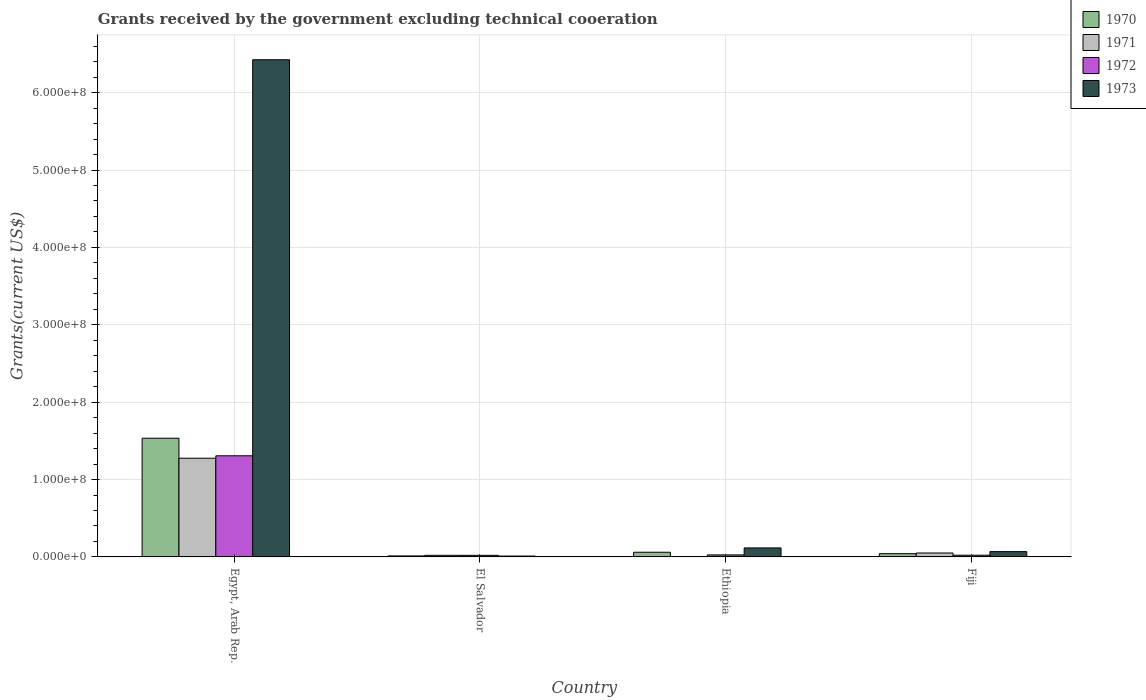How many different coloured bars are there?
Your answer should be compact. 4. How many groups of bars are there?
Offer a very short reply. 4. How many bars are there on the 2nd tick from the left?
Offer a terse response. 4. What is the label of the 2nd group of bars from the left?
Keep it short and to the point. El Salvador. In how many cases, is the number of bars for a given country not equal to the number of legend labels?
Offer a very short reply. 1. What is the total grants received by the government in 1973 in Fiji?
Offer a terse response. 6.86e+06. Across all countries, what is the maximum total grants received by the government in 1973?
Ensure brevity in your answer.  6.43e+08. Across all countries, what is the minimum total grants received by the government in 1973?
Your response must be concise. 1.15e+06. In which country was the total grants received by the government in 1970 maximum?
Your answer should be compact. Egypt, Arab Rep. What is the total total grants received by the government in 1971 in the graph?
Your response must be concise. 1.35e+08. What is the difference between the total grants received by the government in 1972 in El Salvador and that in Fiji?
Keep it short and to the point. -1.60e+05. What is the difference between the total grants received by the government in 1973 in El Salvador and the total grants received by the government in 1972 in Ethiopia?
Keep it short and to the point. -1.45e+06. What is the average total grants received by the government in 1973 per country?
Make the answer very short. 1.66e+08. What is the difference between the total grants received by the government of/in 1973 and total grants received by the government of/in 1970 in Ethiopia?
Keep it short and to the point. 5.60e+06. What is the ratio of the total grants received by the government in 1970 in El Salvador to that in Ethiopia?
Make the answer very short. 0.22. Is the difference between the total grants received by the government in 1973 in Ethiopia and Fiji greater than the difference between the total grants received by the government in 1970 in Ethiopia and Fiji?
Offer a terse response. Yes. What is the difference between the highest and the second highest total grants received by the government in 1972?
Keep it short and to the point. 1.28e+08. What is the difference between the highest and the lowest total grants received by the government in 1973?
Provide a short and direct response. 6.41e+08. In how many countries, is the total grants received by the government in 1971 greater than the average total grants received by the government in 1971 taken over all countries?
Offer a terse response. 1. Is the sum of the total grants received by the government in 1972 in Egypt, Arab Rep. and Ethiopia greater than the maximum total grants received by the government in 1971 across all countries?
Offer a very short reply. Yes. Is it the case that in every country, the sum of the total grants received by the government in 1970 and total grants received by the government in 1971 is greater than the total grants received by the government in 1973?
Provide a succinct answer. No. How many bars are there?
Ensure brevity in your answer.  15. How many countries are there in the graph?
Keep it short and to the point. 4. Does the graph contain grids?
Offer a terse response. Yes. How are the legend labels stacked?
Give a very brief answer. Vertical. What is the title of the graph?
Ensure brevity in your answer.  Grants received by the government excluding technical cooeration. Does "1980" appear as one of the legend labels in the graph?
Make the answer very short. No. What is the label or title of the Y-axis?
Keep it short and to the point. Grants(current US$). What is the Grants(current US$) in 1970 in Egypt, Arab Rep.?
Your answer should be compact. 1.53e+08. What is the Grants(current US$) in 1971 in Egypt, Arab Rep.?
Your response must be concise. 1.28e+08. What is the Grants(current US$) in 1972 in Egypt, Arab Rep.?
Give a very brief answer. 1.31e+08. What is the Grants(current US$) of 1973 in Egypt, Arab Rep.?
Keep it short and to the point. 6.43e+08. What is the Grants(current US$) in 1970 in El Salvador?
Your answer should be compact. 1.32e+06. What is the Grants(current US$) in 1971 in El Salvador?
Ensure brevity in your answer.  2.08e+06. What is the Grants(current US$) in 1972 in El Salvador?
Your answer should be very brief. 2.07e+06. What is the Grants(current US$) in 1973 in El Salvador?
Provide a succinct answer. 1.15e+06. What is the Grants(current US$) in 1970 in Ethiopia?
Provide a succinct answer. 6.05e+06. What is the Grants(current US$) of 1971 in Ethiopia?
Ensure brevity in your answer.  0. What is the Grants(current US$) of 1972 in Ethiopia?
Keep it short and to the point. 2.60e+06. What is the Grants(current US$) in 1973 in Ethiopia?
Keep it short and to the point. 1.16e+07. What is the Grants(current US$) in 1970 in Fiji?
Your response must be concise. 4.19e+06. What is the Grants(current US$) in 1971 in Fiji?
Make the answer very short. 5.09e+06. What is the Grants(current US$) of 1972 in Fiji?
Keep it short and to the point. 2.23e+06. What is the Grants(current US$) of 1973 in Fiji?
Provide a succinct answer. 6.86e+06. Across all countries, what is the maximum Grants(current US$) in 1970?
Your answer should be compact. 1.53e+08. Across all countries, what is the maximum Grants(current US$) of 1971?
Provide a short and direct response. 1.28e+08. Across all countries, what is the maximum Grants(current US$) in 1972?
Your answer should be compact. 1.31e+08. Across all countries, what is the maximum Grants(current US$) of 1973?
Make the answer very short. 6.43e+08. Across all countries, what is the minimum Grants(current US$) of 1970?
Keep it short and to the point. 1.32e+06. Across all countries, what is the minimum Grants(current US$) in 1971?
Ensure brevity in your answer.  0. Across all countries, what is the minimum Grants(current US$) of 1972?
Your response must be concise. 2.07e+06. Across all countries, what is the minimum Grants(current US$) of 1973?
Offer a terse response. 1.15e+06. What is the total Grants(current US$) of 1970 in the graph?
Offer a very short reply. 1.65e+08. What is the total Grants(current US$) in 1971 in the graph?
Your response must be concise. 1.35e+08. What is the total Grants(current US$) in 1972 in the graph?
Your answer should be compact. 1.38e+08. What is the total Grants(current US$) of 1973 in the graph?
Offer a very short reply. 6.62e+08. What is the difference between the Grants(current US$) in 1970 in Egypt, Arab Rep. and that in El Salvador?
Your answer should be very brief. 1.52e+08. What is the difference between the Grants(current US$) in 1971 in Egypt, Arab Rep. and that in El Salvador?
Make the answer very short. 1.26e+08. What is the difference between the Grants(current US$) in 1972 in Egypt, Arab Rep. and that in El Salvador?
Offer a terse response. 1.29e+08. What is the difference between the Grants(current US$) in 1973 in Egypt, Arab Rep. and that in El Salvador?
Provide a succinct answer. 6.41e+08. What is the difference between the Grants(current US$) in 1970 in Egypt, Arab Rep. and that in Ethiopia?
Your answer should be compact. 1.47e+08. What is the difference between the Grants(current US$) of 1972 in Egypt, Arab Rep. and that in Ethiopia?
Offer a very short reply. 1.28e+08. What is the difference between the Grants(current US$) of 1973 in Egypt, Arab Rep. and that in Ethiopia?
Provide a succinct answer. 6.31e+08. What is the difference between the Grants(current US$) of 1970 in Egypt, Arab Rep. and that in Fiji?
Your answer should be compact. 1.49e+08. What is the difference between the Grants(current US$) of 1971 in Egypt, Arab Rep. and that in Fiji?
Keep it short and to the point. 1.22e+08. What is the difference between the Grants(current US$) in 1972 in Egypt, Arab Rep. and that in Fiji?
Your answer should be compact. 1.28e+08. What is the difference between the Grants(current US$) in 1973 in Egypt, Arab Rep. and that in Fiji?
Make the answer very short. 6.36e+08. What is the difference between the Grants(current US$) of 1970 in El Salvador and that in Ethiopia?
Make the answer very short. -4.73e+06. What is the difference between the Grants(current US$) in 1972 in El Salvador and that in Ethiopia?
Your answer should be compact. -5.30e+05. What is the difference between the Grants(current US$) of 1973 in El Salvador and that in Ethiopia?
Your response must be concise. -1.05e+07. What is the difference between the Grants(current US$) of 1970 in El Salvador and that in Fiji?
Provide a succinct answer. -2.87e+06. What is the difference between the Grants(current US$) of 1971 in El Salvador and that in Fiji?
Ensure brevity in your answer.  -3.01e+06. What is the difference between the Grants(current US$) in 1972 in El Salvador and that in Fiji?
Your answer should be very brief. -1.60e+05. What is the difference between the Grants(current US$) of 1973 in El Salvador and that in Fiji?
Provide a succinct answer. -5.71e+06. What is the difference between the Grants(current US$) in 1970 in Ethiopia and that in Fiji?
Keep it short and to the point. 1.86e+06. What is the difference between the Grants(current US$) in 1973 in Ethiopia and that in Fiji?
Your answer should be compact. 4.79e+06. What is the difference between the Grants(current US$) in 1970 in Egypt, Arab Rep. and the Grants(current US$) in 1971 in El Salvador?
Make the answer very short. 1.51e+08. What is the difference between the Grants(current US$) of 1970 in Egypt, Arab Rep. and the Grants(current US$) of 1972 in El Salvador?
Offer a very short reply. 1.51e+08. What is the difference between the Grants(current US$) of 1970 in Egypt, Arab Rep. and the Grants(current US$) of 1973 in El Salvador?
Your answer should be very brief. 1.52e+08. What is the difference between the Grants(current US$) of 1971 in Egypt, Arab Rep. and the Grants(current US$) of 1972 in El Salvador?
Ensure brevity in your answer.  1.26e+08. What is the difference between the Grants(current US$) of 1971 in Egypt, Arab Rep. and the Grants(current US$) of 1973 in El Salvador?
Your answer should be compact. 1.26e+08. What is the difference between the Grants(current US$) of 1972 in Egypt, Arab Rep. and the Grants(current US$) of 1973 in El Salvador?
Keep it short and to the point. 1.30e+08. What is the difference between the Grants(current US$) in 1970 in Egypt, Arab Rep. and the Grants(current US$) in 1972 in Ethiopia?
Provide a succinct answer. 1.51e+08. What is the difference between the Grants(current US$) of 1970 in Egypt, Arab Rep. and the Grants(current US$) of 1973 in Ethiopia?
Ensure brevity in your answer.  1.42e+08. What is the difference between the Grants(current US$) in 1971 in Egypt, Arab Rep. and the Grants(current US$) in 1972 in Ethiopia?
Give a very brief answer. 1.25e+08. What is the difference between the Grants(current US$) of 1971 in Egypt, Arab Rep. and the Grants(current US$) of 1973 in Ethiopia?
Give a very brief answer. 1.16e+08. What is the difference between the Grants(current US$) in 1972 in Egypt, Arab Rep. and the Grants(current US$) in 1973 in Ethiopia?
Ensure brevity in your answer.  1.19e+08. What is the difference between the Grants(current US$) in 1970 in Egypt, Arab Rep. and the Grants(current US$) in 1971 in Fiji?
Your answer should be very brief. 1.48e+08. What is the difference between the Grants(current US$) of 1970 in Egypt, Arab Rep. and the Grants(current US$) of 1972 in Fiji?
Keep it short and to the point. 1.51e+08. What is the difference between the Grants(current US$) in 1970 in Egypt, Arab Rep. and the Grants(current US$) in 1973 in Fiji?
Your response must be concise. 1.47e+08. What is the difference between the Grants(current US$) in 1971 in Egypt, Arab Rep. and the Grants(current US$) in 1972 in Fiji?
Your answer should be very brief. 1.25e+08. What is the difference between the Grants(current US$) of 1971 in Egypt, Arab Rep. and the Grants(current US$) of 1973 in Fiji?
Your answer should be very brief. 1.21e+08. What is the difference between the Grants(current US$) in 1972 in Egypt, Arab Rep. and the Grants(current US$) in 1973 in Fiji?
Your response must be concise. 1.24e+08. What is the difference between the Grants(current US$) in 1970 in El Salvador and the Grants(current US$) in 1972 in Ethiopia?
Your answer should be very brief. -1.28e+06. What is the difference between the Grants(current US$) in 1970 in El Salvador and the Grants(current US$) in 1973 in Ethiopia?
Offer a very short reply. -1.03e+07. What is the difference between the Grants(current US$) in 1971 in El Salvador and the Grants(current US$) in 1972 in Ethiopia?
Make the answer very short. -5.20e+05. What is the difference between the Grants(current US$) of 1971 in El Salvador and the Grants(current US$) of 1973 in Ethiopia?
Provide a succinct answer. -9.57e+06. What is the difference between the Grants(current US$) of 1972 in El Salvador and the Grants(current US$) of 1973 in Ethiopia?
Your response must be concise. -9.58e+06. What is the difference between the Grants(current US$) in 1970 in El Salvador and the Grants(current US$) in 1971 in Fiji?
Provide a succinct answer. -3.77e+06. What is the difference between the Grants(current US$) of 1970 in El Salvador and the Grants(current US$) of 1972 in Fiji?
Make the answer very short. -9.10e+05. What is the difference between the Grants(current US$) of 1970 in El Salvador and the Grants(current US$) of 1973 in Fiji?
Offer a very short reply. -5.54e+06. What is the difference between the Grants(current US$) of 1971 in El Salvador and the Grants(current US$) of 1972 in Fiji?
Give a very brief answer. -1.50e+05. What is the difference between the Grants(current US$) of 1971 in El Salvador and the Grants(current US$) of 1973 in Fiji?
Your answer should be very brief. -4.78e+06. What is the difference between the Grants(current US$) in 1972 in El Salvador and the Grants(current US$) in 1973 in Fiji?
Your answer should be very brief. -4.79e+06. What is the difference between the Grants(current US$) of 1970 in Ethiopia and the Grants(current US$) of 1971 in Fiji?
Offer a very short reply. 9.60e+05. What is the difference between the Grants(current US$) of 1970 in Ethiopia and the Grants(current US$) of 1972 in Fiji?
Offer a terse response. 3.82e+06. What is the difference between the Grants(current US$) in 1970 in Ethiopia and the Grants(current US$) in 1973 in Fiji?
Make the answer very short. -8.10e+05. What is the difference between the Grants(current US$) of 1972 in Ethiopia and the Grants(current US$) of 1973 in Fiji?
Your response must be concise. -4.26e+06. What is the average Grants(current US$) in 1970 per country?
Offer a very short reply. 4.12e+07. What is the average Grants(current US$) of 1971 per country?
Ensure brevity in your answer.  3.37e+07. What is the average Grants(current US$) of 1972 per country?
Ensure brevity in your answer.  3.44e+07. What is the average Grants(current US$) in 1973 per country?
Give a very brief answer. 1.66e+08. What is the difference between the Grants(current US$) of 1970 and Grants(current US$) of 1971 in Egypt, Arab Rep.?
Your answer should be very brief. 2.58e+07. What is the difference between the Grants(current US$) in 1970 and Grants(current US$) in 1972 in Egypt, Arab Rep.?
Offer a very short reply. 2.27e+07. What is the difference between the Grants(current US$) in 1970 and Grants(current US$) in 1973 in Egypt, Arab Rep.?
Keep it short and to the point. -4.89e+08. What is the difference between the Grants(current US$) in 1971 and Grants(current US$) in 1972 in Egypt, Arab Rep.?
Your response must be concise. -3.12e+06. What is the difference between the Grants(current US$) of 1971 and Grants(current US$) of 1973 in Egypt, Arab Rep.?
Offer a very short reply. -5.15e+08. What is the difference between the Grants(current US$) of 1972 and Grants(current US$) of 1973 in Egypt, Arab Rep.?
Give a very brief answer. -5.12e+08. What is the difference between the Grants(current US$) of 1970 and Grants(current US$) of 1971 in El Salvador?
Offer a very short reply. -7.60e+05. What is the difference between the Grants(current US$) in 1970 and Grants(current US$) in 1972 in El Salvador?
Offer a terse response. -7.50e+05. What is the difference between the Grants(current US$) of 1971 and Grants(current US$) of 1972 in El Salvador?
Provide a short and direct response. 10000. What is the difference between the Grants(current US$) in 1971 and Grants(current US$) in 1973 in El Salvador?
Give a very brief answer. 9.30e+05. What is the difference between the Grants(current US$) in 1972 and Grants(current US$) in 1973 in El Salvador?
Offer a very short reply. 9.20e+05. What is the difference between the Grants(current US$) in 1970 and Grants(current US$) in 1972 in Ethiopia?
Give a very brief answer. 3.45e+06. What is the difference between the Grants(current US$) in 1970 and Grants(current US$) in 1973 in Ethiopia?
Give a very brief answer. -5.60e+06. What is the difference between the Grants(current US$) in 1972 and Grants(current US$) in 1973 in Ethiopia?
Provide a succinct answer. -9.05e+06. What is the difference between the Grants(current US$) in 1970 and Grants(current US$) in 1971 in Fiji?
Offer a terse response. -9.00e+05. What is the difference between the Grants(current US$) of 1970 and Grants(current US$) of 1972 in Fiji?
Offer a very short reply. 1.96e+06. What is the difference between the Grants(current US$) in 1970 and Grants(current US$) in 1973 in Fiji?
Offer a terse response. -2.67e+06. What is the difference between the Grants(current US$) in 1971 and Grants(current US$) in 1972 in Fiji?
Your answer should be compact. 2.86e+06. What is the difference between the Grants(current US$) in 1971 and Grants(current US$) in 1973 in Fiji?
Your response must be concise. -1.77e+06. What is the difference between the Grants(current US$) of 1972 and Grants(current US$) of 1973 in Fiji?
Your response must be concise. -4.63e+06. What is the ratio of the Grants(current US$) of 1970 in Egypt, Arab Rep. to that in El Salvador?
Keep it short and to the point. 116.21. What is the ratio of the Grants(current US$) in 1971 in Egypt, Arab Rep. to that in El Salvador?
Ensure brevity in your answer.  61.34. What is the ratio of the Grants(current US$) in 1972 in Egypt, Arab Rep. to that in El Salvador?
Provide a short and direct response. 63.14. What is the ratio of the Grants(current US$) of 1973 in Egypt, Arab Rep. to that in El Salvador?
Your answer should be compact. 558.74. What is the ratio of the Grants(current US$) in 1970 in Egypt, Arab Rep. to that in Ethiopia?
Give a very brief answer. 25.36. What is the ratio of the Grants(current US$) of 1972 in Egypt, Arab Rep. to that in Ethiopia?
Keep it short and to the point. 50.27. What is the ratio of the Grants(current US$) in 1973 in Egypt, Arab Rep. to that in Ethiopia?
Ensure brevity in your answer.  55.15. What is the ratio of the Grants(current US$) of 1970 in Egypt, Arab Rep. to that in Fiji?
Provide a succinct answer. 36.61. What is the ratio of the Grants(current US$) in 1971 in Egypt, Arab Rep. to that in Fiji?
Keep it short and to the point. 25.06. What is the ratio of the Grants(current US$) in 1972 in Egypt, Arab Rep. to that in Fiji?
Ensure brevity in your answer.  58.61. What is the ratio of the Grants(current US$) in 1973 in Egypt, Arab Rep. to that in Fiji?
Your answer should be very brief. 93.67. What is the ratio of the Grants(current US$) in 1970 in El Salvador to that in Ethiopia?
Offer a very short reply. 0.22. What is the ratio of the Grants(current US$) of 1972 in El Salvador to that in Ethiopia?
Your answer should be very brief. 0.8. What is the ratio of the Grants(current US$) in 1973 in El Salvador to that in Ethiopia?
Provide a short and direct response. 0.1. What is the ratio of the Grants(current US$) of 1970 in El Salvador to that in Fiji?
Provide a succinct answer. 0.32. What is the ratio of the Grants(current US$) in 1971 in El Salvador to that in Fiji?
Provide a succinct answer. 0.41. What is the ratio of the Grants(current US$) in 1972 in El Salvador to that in Fiji?
Provide a short and direct response. 0.93. What is the ratio of the Grants(current US$) in 1973 in El Salvador to that in Fiji?
Offer a terse response. 0.17. What is the ratio of the Grants(current US$) in 1970 in Ethiopia to that in Fiji?
Your response must be concise. 1.44. What is the ratio of the Grants(current US$) in 1972 in Ethiopia to that in Fiji?
Ensure brevity in your answer.  1.17. What is the ratio of the Grants(current US$) in 1973 in Ethiopia to that in Fiji?
Ensure brevity in your answer.  1.7. What is the difference between the highest and the second highest Grants(current US$) in 1970?
Your answer should be very brief. 1.47e+08. What is the difference between the highest and the second highest Grants(current US$) of 1971?
Provide a short and direct response. 1.22e+08. What is the difference between the highest and the second highest Grants(current US$) of 1972?
Provide a succinct answer. 1.28e+08. What is the difference between the highest and the second highest Grants(current US$) in 1973?
Keep it short and to the point. 6.31e+08. What is the difference between the highest and the lowest Grants(current US$) in 1970?
Keep it short and to the point. 1.52e+08. What is the difference between the highest and the lowest Grants(current US$) of 1971?
Offer a very short reply. 1.28e+08. What is the difference between the highest and the lowest Grants(current US$) of 1972?
Provide a short and direct response. 1.29e+08. What is the difference between the highest and the lowest Grants(current US$) in 1973?
Provide a succinct answer. 6.41e+08. 